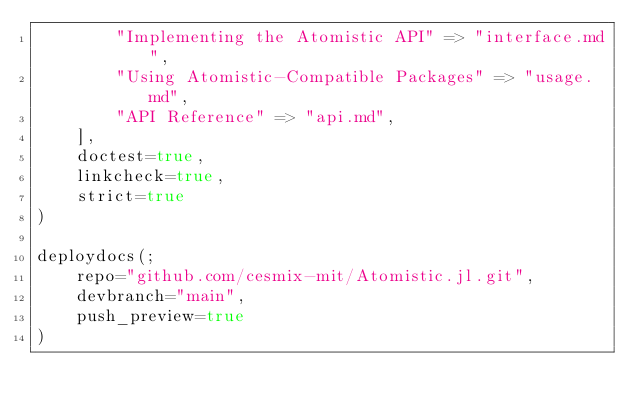<code> <loc_0><loc_0><loc_500><loc_500><_Julia_>        "Implementing the Atomistic API" => "interface.md",
        "Using Atomistic-Compatible Packages" => "usage.md",
        "API Reference" => "api.md",
    ],
    doctest=true,
    linkcheck=true,
    strict=true
)

deploydocs(;
    repo="github.com/cesmix-mit/Atomistic.jl.git",
    devbranch="main",
    push_preview=true
)</code> 